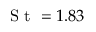<formula> <loc_0><loc_0><loc_500><loc_500>S t = 1 . 8 3</formula> 